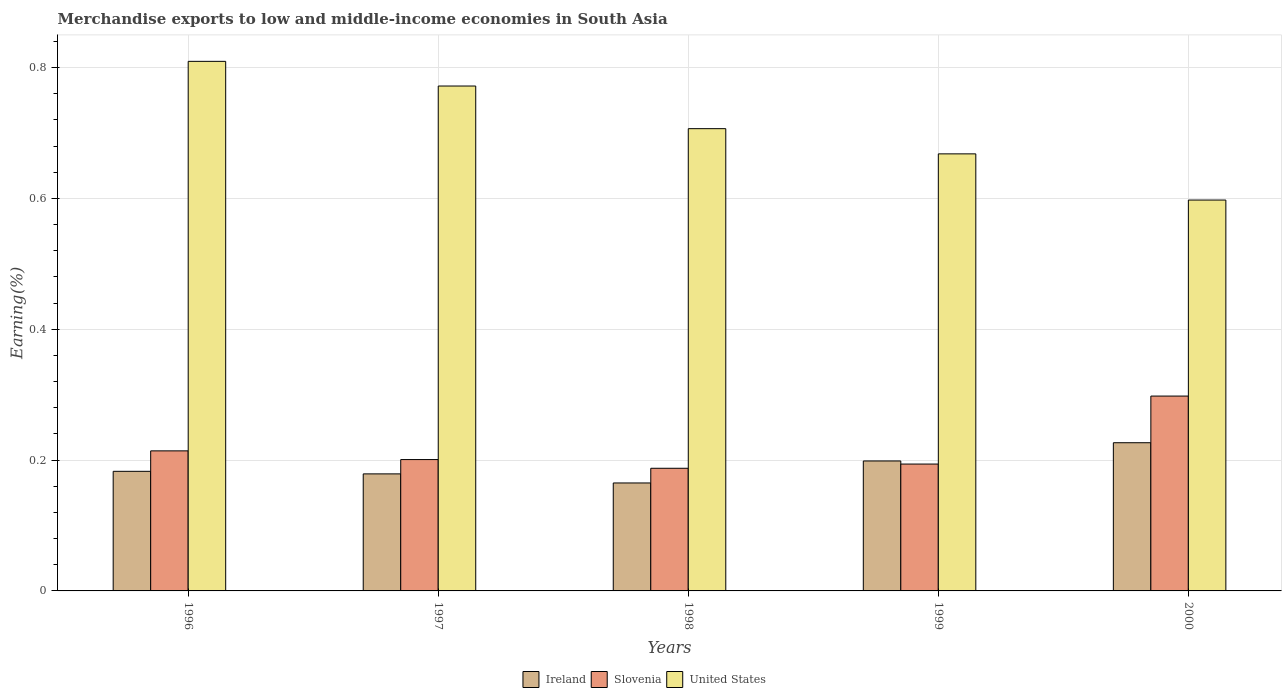How many groups of bars are there?
Provide a succinct answer. 5. Are the number of bars on each tick of the X-axis equal?
Keep it short and to the point. Yes. How many bars are there on the 3rd tick from the right?
Offer a terse response. 3. What is the label of the 1st group of bars from the left?
Your response must be concise. 1996. What is the percentage of amount earned from merchandise exports in Slovenia in 1996?
Give a very brief answer. 0.21. Across all years, what is the maximum percentage of amount earned from merchandise exports in Ireland?
Your answer should be very brief. 0.23. Across all years, what is the minimum percentage of amount earned from merchandise exports in United States?
Offer a terse response. 0.6. In which year was the percentage of amount earned from merchandise exports in United States maximum?
Ensure brevity in your answer.  1996. In which year was the percentage of amount earned from merchandise exports in Ireland minimum?
Keep it short and to the point. 1998. What is the total percentage of amount earned from merchandise exports in United States in the graph?
Provide a succinct answer. 3.55. What is the difference between the percentage of amount earned from merchandise exports in United States in 1998 and that in 1999?
Make the answer very short. 0.04. What is the difference between the percentage of amount earned from merchandise exports in Slovenia in 1998 and the percentage of amount earned from merchandise exports in United States in 1996?
Ensure brevity in your answer.  -0.62. What is the average percentage of amount earned from merchandise exports in Slovenia per year?
Provide a short and direct response. 0.22. In the year 1999, what is the difference between the percentage of amount earned from merchandise exports in United States and percentage of amount earned from merchandise exports in Ireland?
Provide a succinct answer. 0.47. In how many years, is the percentage of amount earned from merchandise exports in Slovenia greater than 0.7200000000000001 %?
Ensure brevity in your answer.  0. What is the ratio of the percentage of amount earned from merchandise exports in Ireland in 1996 to that in 1999?
Your response must be concise. 0.92. Is the percentage of amount earned from merchandise exports in Ireland in 1996 less than that in 1999?
Provide a short and direct response. Yes. What is the difference between the highest and the second highest percentage of amount earned from merchandise exports in Ireland?
Give a very brief answer. 0.03. What is the difference between the highest and the lowest percentage of amount earned from merchandise exports in United States?
Provide a succinct answer. 0.21. In how many years, is the percentage of amount earned from merchandise exports in United States greater than the average percentage of amount earned from merchandise exports in United States taken over all years?
Your answer should be very brief. 2. What does the 3rd bar from the right in 1998 represents?
Offer a terse response. Ireland. How many bars are there?
Give a very brief answer. 15. How many years are there in the graph?
Your response must be concise. 5. Does the graph contain any zero values?
Your answer should be compact. No. Does the graph contain grids?
Make the answer very short. Yes. Where does the legend appear in the graph?
Your answer should be compact. Bottom center. How many legend labels are there?
Your answer should be compact. 3. How are the legend labels stacked?
Your answer should be compact. Horizontal. What is the title of the graph?
Keep it short and to the point. Merchandise exports to low and middle-income economies in South Asia. Does "Kuwait" appear as one of the legend labels in the graph?
Make the answer very short. No. What is the label or title of the X-axis?
Your answer should be very brief. Years. What is the label or title of the Y-axis?
Offer a terse response. Earning(%). What is the Earning(%) in Ireland in 1996?
Your answer should be very brief. 0.18. What is the Earning(%) in Slovenia in 1996?
Your answer should be very brief. 0.21. What is the Earning(%) in United States in 1996?
Keep it short and to the point. 0.81. What is the Earning(%) in Ireland in 1997?
Offer a very short reply. 0.18. What is the Earning(%) of Slovenia in 1997?
Your answer should be very brief. 0.2. What is the Earning(%) of United States in 1997?
Provide a succinct answer. 0.77. What is the Earning(%) in Ireland in 1998?
Provide a short and direct response. 0.17. What is the Earning(%) in Slovenia in 1998?
Ensure brevity in your answer.  0.19. What is the Earning(%) of United States in 1998?
Your response must be concise. 0.71. What is the Earning(%) in Ireland in 1999?
Keep it short and to the point. 0.2. What is the Earning(%) of Slovenia in 1999?
Offer a terse response. 0.19. What is the Earning(%) in United States in 1999?
Your answer should be very brief. 0.67. What is the Earning(%) of Ireland in 2000?
Provide a succinct answer. 0.23. What is the Earning(%) of Slovenia in 2000?
Make the answer very short. 0.3. What is the Earning(%) in United States in 2000?
Provide a succinct answer. 0.6. Across all years, what is the maximum Earning(%) of Ireland?
Keep it short and to the point. 0.23. Across all years, what is the maximum Earning(%) of Slovenia?
Make the answer very short. 0.3. Across all years, what is the maximum Earning(%) in United States?
Provide a short and direct response. 0.81. Across all years, what is the minimum Earning(%) of Ireland?
Provide a short and direct response. 0.17. Across all years, what is the minimum Earning(%) in Slovenia?
Offer a terse response. 0.19. Across all years, what is the minimum Earning(%) in United States?
Ensure brevity in your answer.  0.6. What is the total Earning(%) of Ireland in the graph?
Provide a succinct answer. 0.95. What is the total Earning(%) in Slovenia in the graph?
Your answer should be compact. 1.09. What is the total Earning(%) in United States in the graph?
Make the answer very short. 3.55. What is the difference between the Earning(%) of Ireland in 1996 and that in 1997?
Your answer should be compact. 0. What is the difference between the Earning(%) of Slovenia in 1996 and that in 1997?
Your response must be concise. 0.01. What is the difference between the Earning(%) in United States in 1996 and that in 1997?
Your response must be concise. 0.04. What is the difference between the Earning(%) in Ireland in 1996 and that in 1998?
Offer a terse response. 0.02. What is the difference between the Earning(%) in Slovenia in 1996 and that in 1998?
Make the answer very short. 0.03. What is the difference between the Earning(%) in United States in 1996 and that in 1998?
Your answer should be very brief. 0.1. What is the difference between the Earning(%) in Ireland in 1996 and that in 1999?
Offer a very short reply. -0.02. What is the difference between the Earning(%) of Slovenia in 1996 and that in 1999?
Provide a succinct answer. 0.02. What is the difference between the Earning(%) in United States in 1996 and that in 1999?
Offer a terse response. 0.14. What is the difference between the Earning(%) in Ireland in 1996 and that in 2000?
Offer a terse response. -0.04. What is the difference between the Earning(%) in Slovenia in 1996 and that in 2000?
Provide a succinct answer. -0.08. What is the difference between the Earning(%) of United States in 1996 and that in 2000?
Keep it short and to the point. 0.21. What is the difference between the Earning(%) of Ireland in 1997 and that in 1998?
Your response must be concise. 0.01. What is the difference between the Earning(%) in Slovenia in 1997 and that in 1998?
Your answer should be compact. 0.01. What is the difference between the Earning(%) in United States in 1997 and that in 1998?
Offer a very short reply. 0.07. What is the difference between the Earning(%) in Ireland in 1997 and that in 1999?
Provide a short and direct response. -0.02. What is the difference between the Earning(%) in Slovenia in 1997 and that in 1999?
Your answer should be very brief. 0.01. What is the difference between the Earning(%) of United States in 1997 and that in 1999?
Your answer should be very brief. 0.1. What is the difference between the Earning(%) of Ireland in 1997 and that in 2000?
Provide a succinct answer. -0.05. What is the difference between the Earning(%) of Slovenia in 1997 and that in 2000?
Give a very brief answer. -0.1. What is the difference between the Earning(%) in United States in 1997 and that in 2000?
Your response must be concise. 0.17. What is the difference between the Earning(%) of Ireland in 1998 and that in 1999?
Provide a short and direct response. -0.03. What is the difference between the Earning(%) in Slovenia in 1998 and that in 1999?
Your answer should be very brief. -0.01. What is the difference between the Earning(%) in United States in 1998 and that in 1999?
Offer a very short reply. 0.04. What is the difference between the Earning(%) of Ireland in 1998 and that in 2000?
Your answer should be very brief. -0.06. What is the difference between the Earning(%) in Slovenia in 1998 and that in 2000?
Offer a terse response. -0.11. What is the difference between the Earning(%) of United States in 1998 and that in 2000?
Your response must be concise. 0.11. What is the difference between the Earning(%) in Ireland in 1999 and that in 2000?
Provide a short and direct response. -0.03. What is the difference between the Earning(%) in Slovenia in 1999 and that in 2000?
Provide a short and direct response. -0.1. What is the difference between the Earning(%) of United States in 1999 and that in 2000?
Provide a succinct answer. 0.07. What is the difference between the Earning(%) in Ireland in 1996 and the Earning(%) in Slovenia in 1997?
Provide a succinct answer. -0.02. What is the difference between the Earning(%) in Ireland in 1996 and the Earning(%) in United States in 1997?
Your answer should be very brief. -0.59. What is the difference between the Earning(%) in Slovenia in 1996 and the Earning(%) in United States in 1997?
Make the answer very short. -0.56. What is the difference between the Earning(%) in Ireland in 1996 and the Earning(%) in Slovenia in 1998?
Offer a very short reply. -0. What is the difference between the Earning(%) of Ireland in 1996 and the Earning(%) of United States in 1998?
Offer a terse response. -0.52. What is the difference between the Earning(%) of Slovenia in 1996 and the Earning(%) of United States in 1998?
Offer a very short reply. -0.49. What is the difference between the Earning(%) in Ireland in 1996 and the Earning(%) in Slovenia in 1999?
Keep it short and to the point. -0.01. What is the difference between the Earning(%) in Ireland in 1996 and the Earning(%) in United States in 1999?
Your response must be concise. -0.49. What is the difference between the Earning(%) in Slovenia in 1996 and the Earning(%) in United States in 1999?
Ensure brevity in your answer.  -0.45. What is the difference between the Earning(%) of Ireland in 1996 and the Earning(%) of Slovenia in 2000?
Your answer should be very brief. -0.12. What is the difference between the Earning(%) in Ireland in 1996 and the Earning(%) in United States in 2000?
Provide a short and direct response. -0.41. What is the difference between the Earning(%) of Slovenia in 1996 and the Earning(%) of United States in 2000?
Your response must be concise. -0.38. What is the difference between the Earning(%) of Ireland in 1997 and the Earning(%) of Slovenia in 1998?
Offer a very short reply. -0.01. What is the difference between the Earning(%) in Ireland in 1997 and the Earning(%) in United States in 1998?
Your answer should be compact. -0.53. What is the difference between the Earning(%) in Slovenia in 1997 and the Earning(%) in United States in 1998?
Offer a very short reply. -0.51. What is the difference between the Earning(%) in Ireland in 1997 and the Earning(%) in Slovenia in 1999?
Provide a succinct answer. -0.01. What is the difference between the Earning(%) of Ireland in 1997 and the Earning(%) of United States in 1999?
Ensure brevity in your answer.  -0.49. What is the difference between the Earning(%) in Slovenia in 1997 and the Earning(%) in United States in 1999?
Your answer should be compact. -0.47. What is the difference between the Earning(%) in Ireland in 1997 and the Earning(%) in Slovenia in 2000?
Provide a short and direct response. -0.12. What is the difference between the Earning(%) in Ireland in 1997 and the Earning(%) in United States in 2000?
Your response must be concise. -0.42. What is the difference between the Earning(%) of Slovenia in 1997 and the Earning(%) of United States in 2000?
Your response must be concise. -0.4. What is the difference between the Earning(%) in Ireland in 1998 and the Earning(%) in Slovenia in 1999?
Ensure brevity in your answer.  -0.03. What is the difference between the Earning(%) of Ireland in 1998 and the Earning(%) of United States in 1999?
Make the answer very short. -0.5. What is the difference between the Earning(%) in Slovenia in 1998 and the Earning(%) in United States in 1999?
Your response must be concise. -0.48. What is the difference between the Earning(%) in Ireland in 1998 and the Earning(%) in Slovenia in 2000?
Your response must be concise. -0.13. What is the difference between the Earning(%) in Ireland in 1998 and the Earning(%) in United States in 2000?
Your answer should be compact. -0.43. What is the difference between the Earning(%) in Slovenia in 1998 and the Earning(%) in United States in 2000?
Provide a short and direct response. -0.41. What is the difference between the Earning(%) of Ireland in 1999 and the Earning(%) of Slovenia in 2000?
Offer a very short reply. -0.1. What is the difference between the Earning(%) of Ireland in 1999 and the Earning(%) of United States in 2000?
Offer a very short reply. -0.4. What is the difference between the Earning(%) of Slovenia in 1999 and the Earning(%) of United States in 2000?
Provide a succinct answer. -0.4. What is the average Earning(%) in Ireland per year?
Your response must be concise. 0.19. What is the average Earning(%) in Slovenia per year?
Make the answer very short. 0.22. What is the average Earning(%) of United States per year?
Your answer should be compact. 0.71. In the year 1996, what is the difference between the Earning(%) of Ireland and Earning(%) of Slovenia?
Give a very brief answer. -0.03. In the year 1996, what is the difference between the Earning(%) of Ireland and Earning(%) of United States?
Your answer should be very brief. -0.63. In the year 1996, what is the difference between the Earning(%) of Slovenia and Earning(%) of United States?
Make the answer very short. -0.6. In the year 1997, what is the difference between the Earning(%) of Ireland and Earning(%) of Slovenia?
Make the answer very short. -0.02. In the year 1997, what is the difference between the Earning(%) of Ireland and Earning(%) of United States?
Your answer should be very brief. -0.59. In the year 1997, what is the difference between the Earning(%) of Slovenia and Earning(%) of United States?
Your answer should be compact. -0.57. In the year 1998, what is the difference between the Earning(%) in Ireland and Earning(%) in Slovenia?
Offer a very short reply. -0.02. In the year 1998, what is the difference between the Earning(%) of Ireland and Earning(%) of United States?
Make the answer very short. -0.54. In the year 1998, what is the difference between the Earning(%) in Slovenia and Earning(%) in United States?
Provide a succinct answer. -0.52. In the year 1999, what is the difference between the Earning(%) in Ireland and Earning(%) in Slovenia?
Make the answer very short. 0. In the year 1999, what is the difference between the Earning(%) in Ireland and Earning(%) in United States?
Offer a terse response. -0.47. In the year 1999, what is the difference between the Earning(%) in Slovenia and Earning(%) in United States?
Provide a succinct answer. -0.47. In the year 2000, what is the difference between the Earning(%) in Ireland and Earning(%) in Slovenia?
Ensure brevity in your answer.  -0.07. In the year 2000, what is the difference between the Earning(%) of Ireland and Earning(%) of United States?
Keep it short and to the point. -0.37. In the year 2000, what is the difference between the Earning(%) in Slovenia and Earning(%) in United States?
Your answer should be compact. -0.3. What is the ratio of the Earning(%) in Slovenia in 1996 to that in 1997?
Offer a very short reply. 1.07. What is the ratio of the Earning(%) of United States in 1996 to that in 1997?
Provide a short and direct response. 1.05. What is the ratio of the Earning(%) in Ireland in 1996 to that in 1998?
Make the answer very short. 1.11. What is the ratio of the Earning(%) of Slovenia in 1996 to that in 1998?
Provide a succinct answer. 1.14. What is the ratio of the Earning(%) of United States in 1996 to that in 1998?
Ensure brevity in your answer.  1.15. What is the ratio of the Earning(%) of Ireland in 1996 to that in 1999?
Provide a short and direct response. 0.92. What is the ratio of the Earning(%) in Slovenia in 1996 to that in 1999?
Give a very brief answer. 1.1. What is the ratio of the Earning(%) of United States in 1996 to that in 1999?
Provide a short and direct response. 1.21. What is the ratio of the Earning(%) of Ireland in 1996 to that in 2000?
Offer a very short reply. 0.81. What is the ratio of the Earning(%) in Slovenia in 1996 to that in 2000?
Your answer should be very brief. 0.72. What is the ratio of the Earning(%) of United States in 1996 to that in 2000?
Provide a succinct answer. 1.35. What is the ratio of the Earning(%) of Ireland in 1997 to that in 1998?
Provide a succinct answer. 1.08. What is the ratio of the Earning(%) of Slovenia in 1997 to that in 1998?
Provide a short and direct response. 1.07. What is the ratio of the Earning(%) of United States in 1997 to that in 1998?
Give a very brief answer. 1.09. What is the ratio of the Earning(%) in Ireland in 1997 to that in 1999?
Your answer should be very brief. 0.9. What is the ratio of the Earning(%) in Slovenia in 1997 to that in 1999?
Make the answer very short. 1.04. What is the ratio of the Earning(%) in United States in 1997 to that in 1999?
Offer a terse response. 1.16. What is the ratio of the Earning(%) in Ireland in 1997 to that in 2000?
Give a very brief answer. 0.79. What is the ratio of the Earning(%) of Slovenia in 1997 to that in 2000?
Give a very brief answer. 0.67. What is the ratio of the Earning(%) in United States in 1997 to that in 2000?
Provide a succinct answer. 1.29. What is the ratio of the Earning(%) in Ireland in 1998 to that in 1999?
Offer a very short reply. 0.83. What is the ratio of the Earning(%) of Slovenia in 1998 to that in 1999?
Provide a succinct answer. 0.97. What is the ratio of the Earning(%) of United States in 1998 to that in 1999?
Your response must be concise. 1.06. What is the ratio of the Earning(%) in Ireland in 1998 to that in 2000?
Your response must be concise. 0.73. What is the ratio of the Earning(%) of Slovenia in 1998 to that in 2000?
Offer a terse response. 0.63. What is the ratio of the Earning(%) in United States in 1998 to that in 2000?
Give a very brief answer. 1.18. What is the ratio of the Earning(%) in Ireland in 1999 to that in 2000?
Provide a short and direct response. 0.88. What is the ratio of the Earning(%) of Slovenia in 1999 to that in 2000?
Provide a short and direct response. 0.65. What is the ratio of the Earning(%) of United States in 1999 to that in 2000?
Your answer should be compact. 1.12. What is the difference between the highest and the second highest Earning(%) in Ireland?
Offer a very short reply. 0.03. What is the difference between the highest and the second highest Earning(%) in Slovenia?
Your answer should be very brief. 0.08. What is the difference between the highest and the second highest Earning(%) of United States?
Your answer should be compact. 0.04. What is the difference between the highest and the lowest Earning(%) in Ireland?
Provide a short and direct response. 0.06. What is the difference between the highest and the lowest Earning(%) in Slovenia?
Offer a very short reply. 0.11. What is the difference between the highest and the lowest Earning(%) in United States?
Provide a succinct answer. 0.21. 